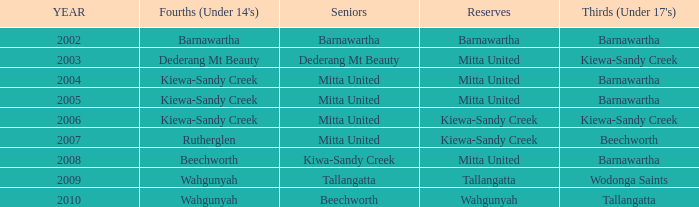Which Fourths (Under 14's) have Seniors of dederang mt beauty? Dederang Mt Beauty. 